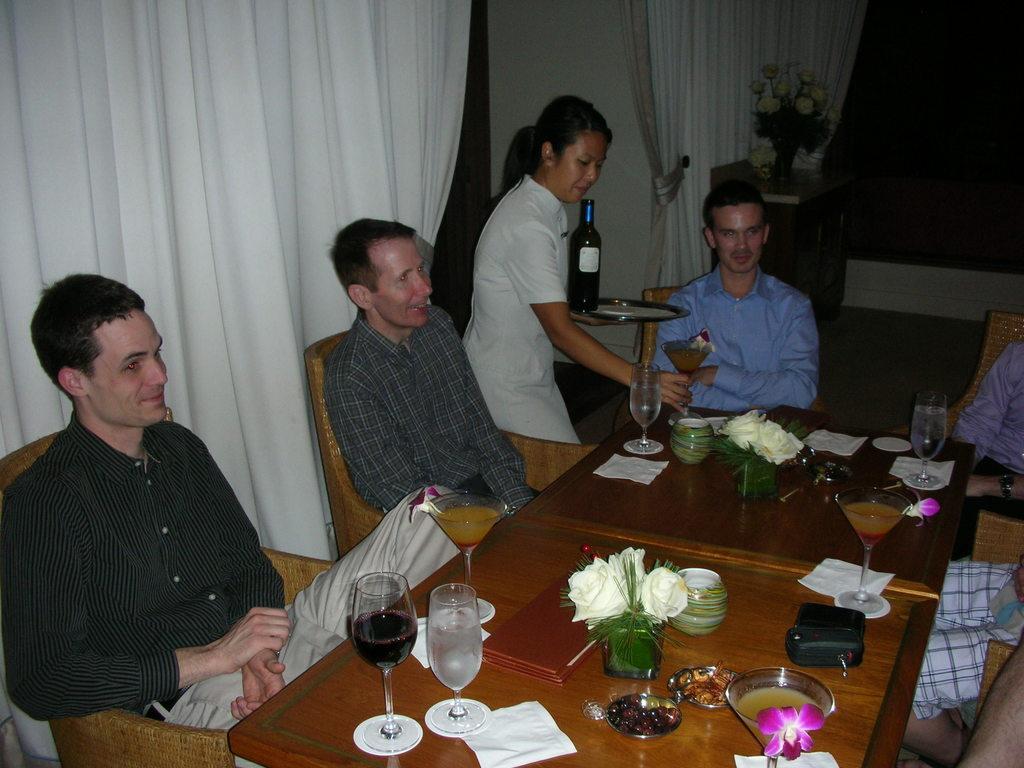Can you describe this image briefly? In this image, group of people are sat on the chair and they are smiling. In the middle, we can see tables, few items are placed on it. The middle, the woman is holding glass and plate, there is a bottle on it. And the background, we can see flower vase, wooden table, curtain and white wall. 